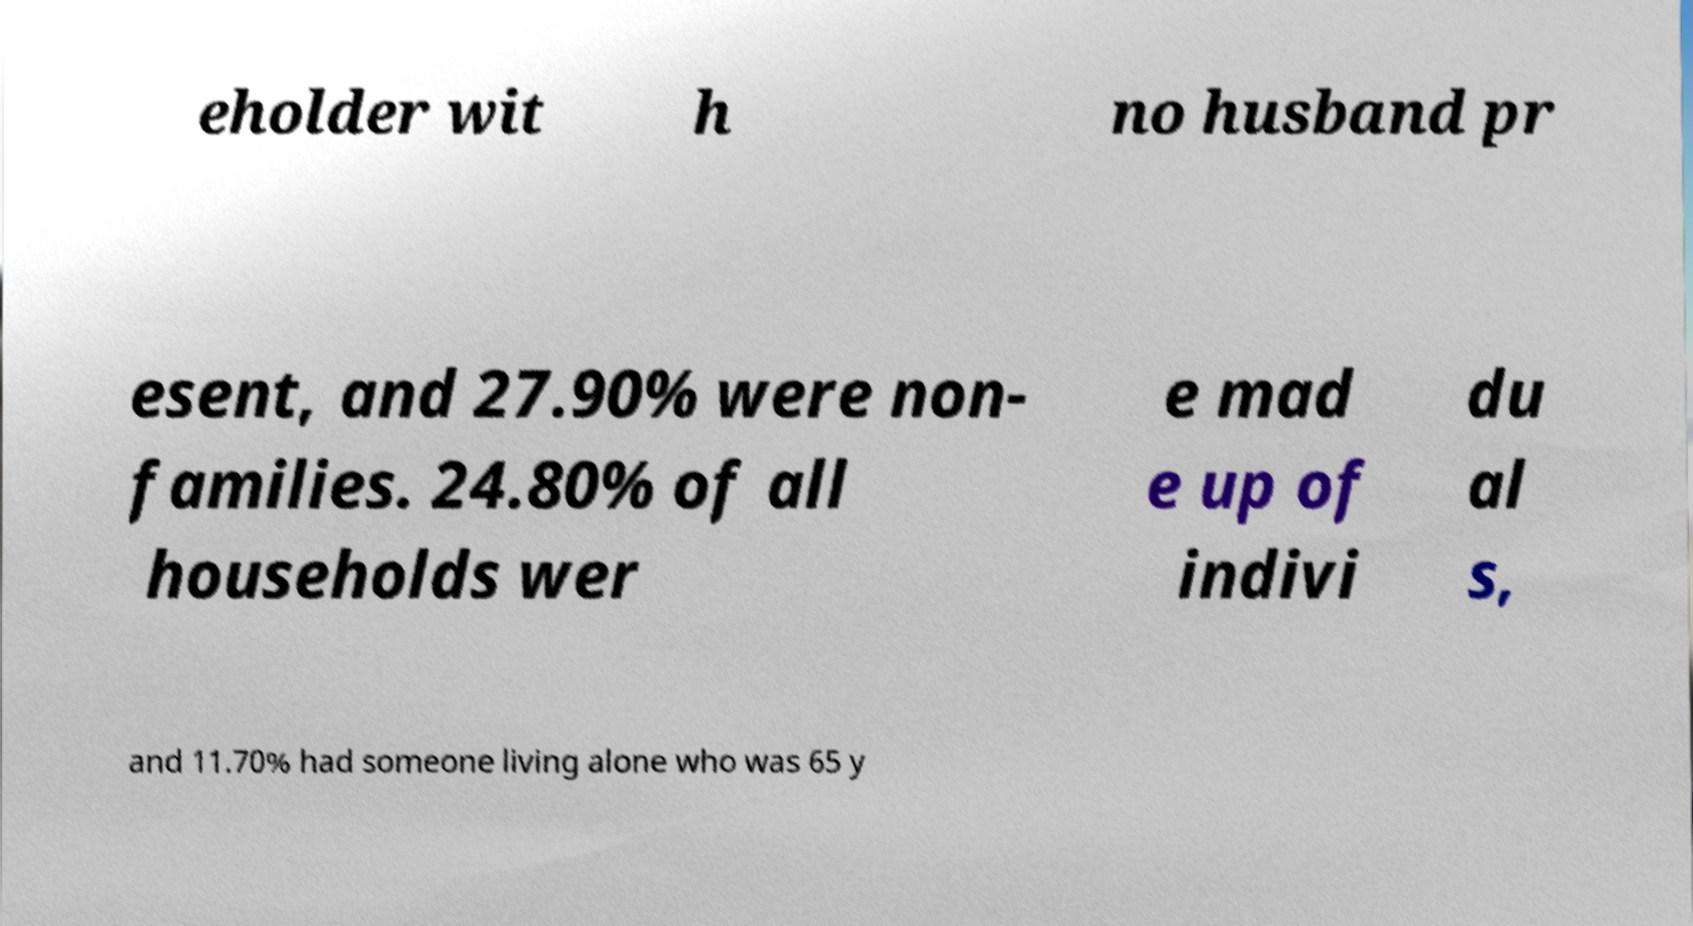For documentation purposes, I need the text within this image transcribed. Could you provide that? eholder wit h no husband pr esent, and 27.90% were non- families. 24.80% of all households wer e mad e up of indivi du al s, and 11.70% had someone living alone who was 65 y 